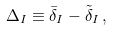Convert formula to latex. <formula><loc_0><loc_0><loc_500><loc_500>\Delta _ { I } \equiv \bar { \delta } _ { I } - \tilde { \delta } _ { I } \, ,</formula> 